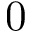Convert formula to latex. <formula><loc_0><loc_0><loc_500><loc_500>0</formula> 